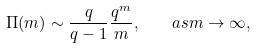Convert formula to latex. <formula><loc_0><loc_0><loc_500><loc_500>\Pi ( m ) \sim \frac { q } { q - 1 } \frac { q ^ { m } } { m } , \quad a s m \to \infty ,</formula> 